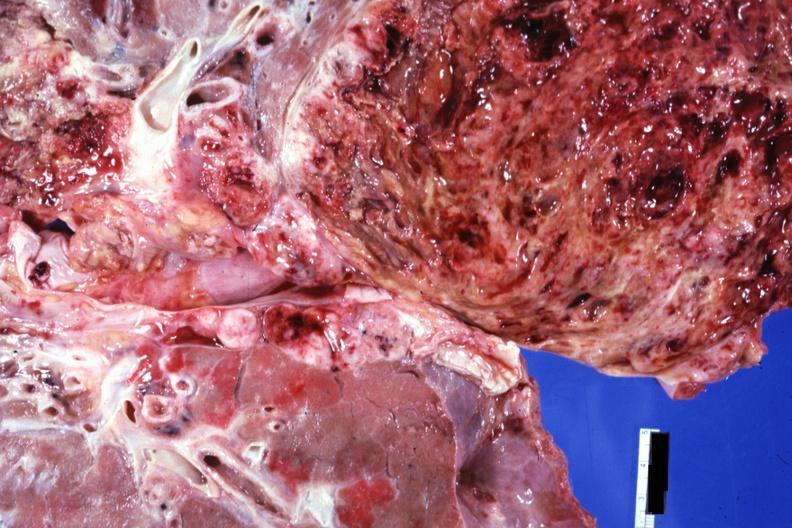what cut surface?
Answer the question using a single word or phrase. Close-up view of tumor 